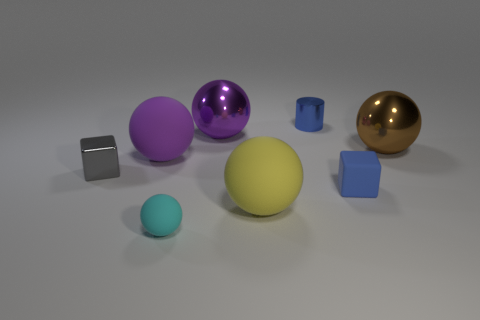Subtract all large purple shiny balls. How many balls are left? 4 Add 2 green shiny cubes. How many objects exist? 10 Subtract all brown blocks. How many purple spheres are left? 2 Subtract all brown spheres. How many spheres are left? 4 Subtract all cylinders. How many objects are left? 7 Subtract all small cyan spheres. Subtract all purple rubber things. How many objects are left? 6 Add 3 small rubber things. How many small rubber things are left? 5 Add 8 rubber blocks. How many rubber blocks exist? 9 Subtract 0 red spheres. How many objects are left? 8 Subtract all green cubes. Subtract all gray balls. How many cubes are left? 2 